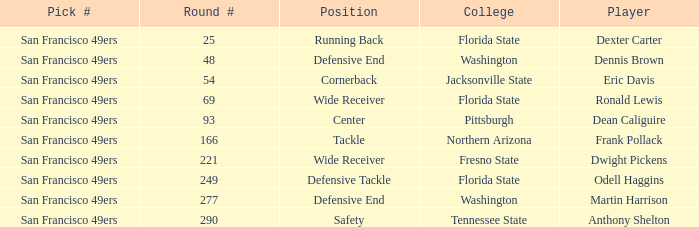Parse the table in full. {'header': ['Pick #', 'Round #', 'Position', 'College', 'Player'], 'rows': [['San Francisco 49ers', '25', 'Running Back', 'Florida State', 'Dexter Carter'], ['San Francisco 49ers', '48', 'Defensive End', 'Washington', 'Dennis Brown'], ['San Francisco 49ers', '54', 'Cornerback', 'Jacksonville State', 'Eric Davis'], ['San Francisco 49ers', '69', 'Wide Receiver', 'Florida State', 'Ronald Lewis'], ['San Francisco 49ers', '93', 'Center', 'Pittsburgh', 'Dean Caliguire'], ['San Francisco 49ers', '166', 'Tackle', 'Northern Arizona', 'Frank Pollack'], ['San Francisco 49ers', '221', 'Wide Receiver', 'Fresno State', 'Dwight Pickens'], ['San Francisco 49ers', '249', 'Defensive Tackle', 'Florida State', 'Odell Haggins'], ['San Francisco 49ers', '277', 'Defensive End', 'Washington', 'Martin Harrison'], ['San Francisco 49ers', '290', 'Safety', 'Tennessee State', 'Anthony Shelton']]} What is the College with a Player that is dean caliguire? Pittsburgh. 